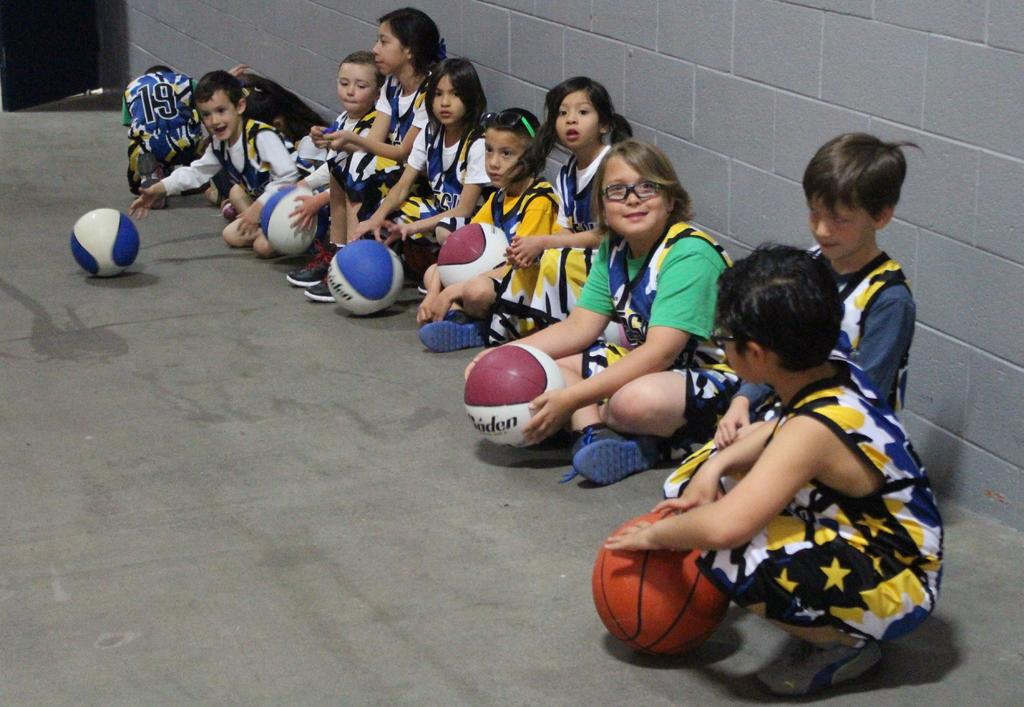What are the kids in the image doing? The kids in the image are sitting. What objects are some of the kids holding? Some of the kids are holding balls. What can be seen in the background of the image? There are two bags in the background of the image. What is on the right side of the image? There is a wall on the right side of the image. How many vacation spots can be seen in the image? There is no reference to vacation spots in the image; it features kids sitting and holding balls, with bags in the background and a wall on the right side. 